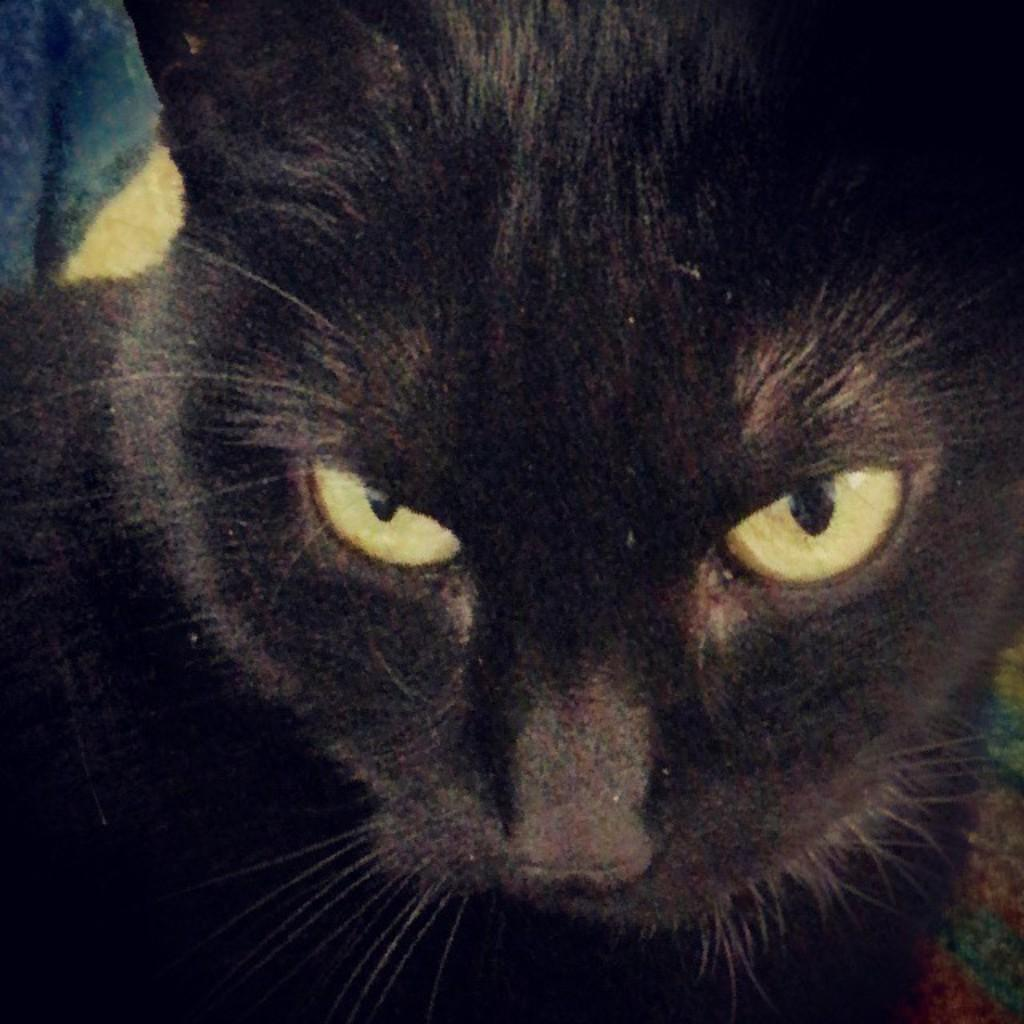What type of animal is in the image? There is a cat in the image. Can you describe the color of the cat? The cat is black in color. What time does the manager arrive at the bushes in the image? There is no manager or bushes present in the image; it only features a black cat. 